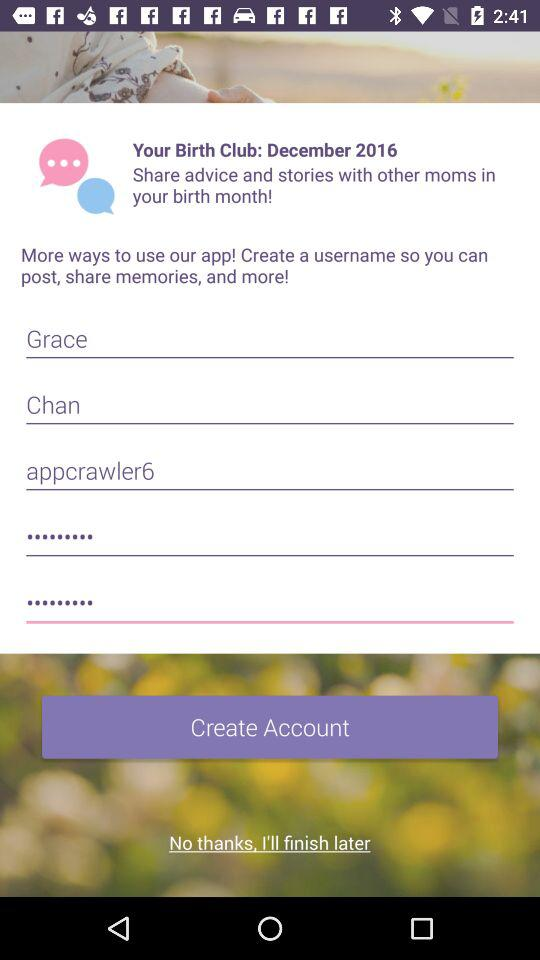What is the name of the user? The name of the user is Grace Chan. 